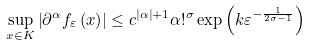<formula> <loc_0><loc_0><loc_500><loc_500>\sup _ { x \in K } \left | \partial ^ { \alpha } f _ { \varepsilon } \left ( x \right ) \right | \leq c ^ { \left | \alpha \right | + 1 } \alpha ! ^ { \sigma } \exp \left ( k \varepsilon ^ { - \frac { 1 } { 2 \sigma - 1 } } \right )</formula> 